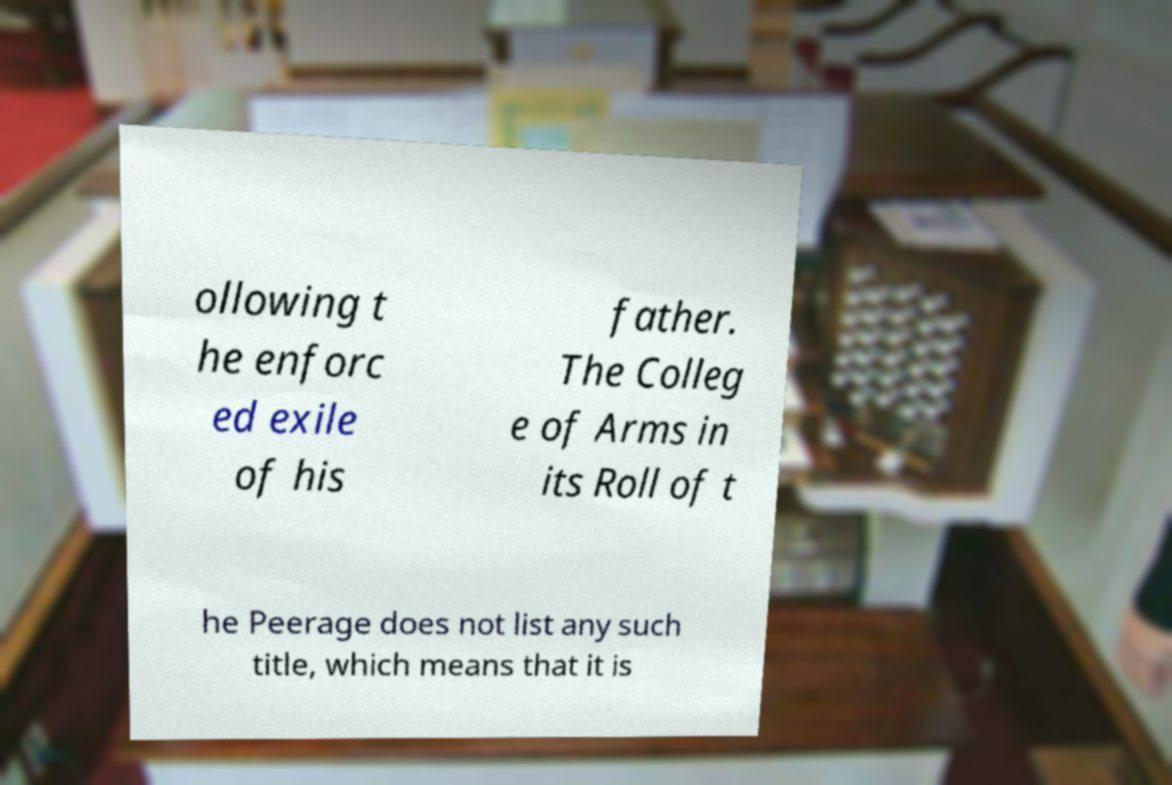I need the written content from this picture converted into text. Can you do that? ollowing t he enforc ed exile of his father. The Colleg e of Arms in its Roll of t he Peerage does not list any such title, which means that it is 